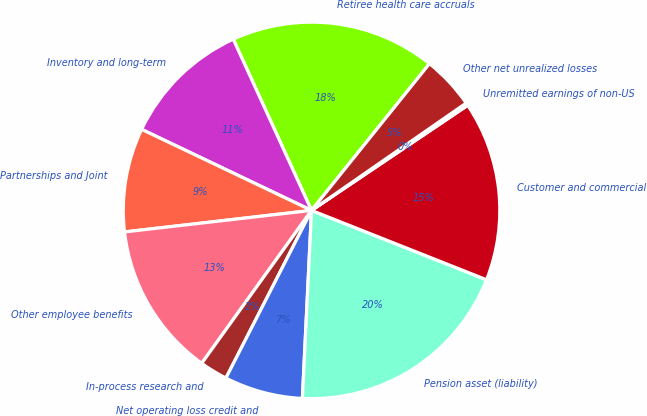Convert chart. <chart><loc_0><loc_0><loc_500><loc_500><pie_chart><fcel>Retiree health care accruals<fcel>Inventory and long-term<fcel>Partnerships and Joint<fcel>Other employee benefits<fcel>In-process research and<fcel>Net operating loss credit and<fcel>Pension asset (liability)<fcel>Customer and commercial<fcel>Unremitted earnings of non-US<fcel>Other net unrealized losses<nl><fcel>17.6%<fcel>11.09%<fcel>8.91%<fcel>13.26%<fcel>2.4%<fcel>6.74%<fcel>19.77%<fcel>15.43%<fcel>0.23%<fcel>4.57%<nl></chart> 